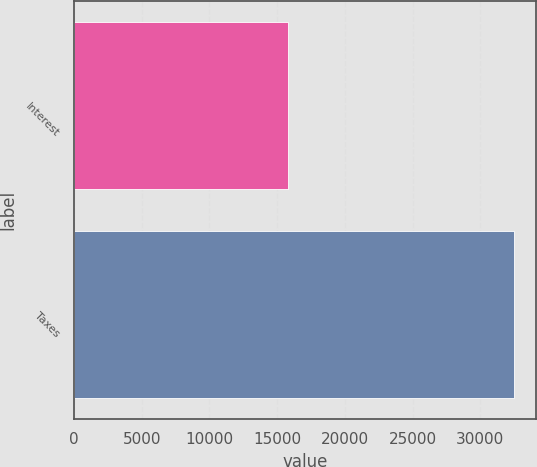<chart> <loc_0><loc_0><loc_500><loc_500><bar_chart><fcel>Interest<fcel>Taxes<nl><fcel>15815<fcel>32465<nl></chart> 